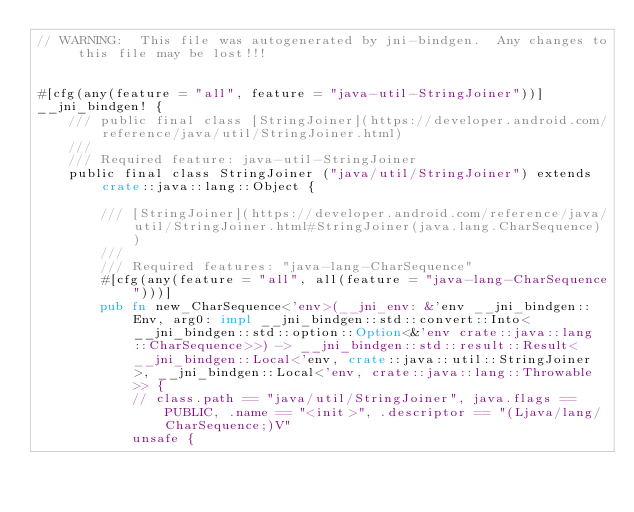Convert code to text. <code><loc_0><loc_0><loc_500><loc_500><_Rust_>// WARNING:  This file was autogenerated by jni-bindgen.  Any changes to this file may be lost!!!


#[cfg(any(feature = "all", feature = "java-util-StringJoiner"))]
__jni_bindgen! {
    /// public final class [StringJoiner](https://developer.android.com/reference/java/util/StringJoiner.html)
    ///
    /// Required feature: java-util-StringJoiner
    public final class StringJoiner ("java/util/StringJoiner") extends crate::java::lang::Object {

        /// [StringJoiner](https://developer.android.com/reference/java/util/StringJoiner.html#StringJoiner(java.lang.CharSequence))
        ///
        /// Required features: "java-lang-CharSequence"
        #[cfg(any(feature = "all", all(feature = "java-lang-CharSequence")))]
        pub fn new_CharSequence<'env>(__jni_env: &'env __jni_bindgen::Env, arg0: impl __jni_bindgen::std::convert::Into<__jni_bindgen::std::option::Option<&'env crate::java::lang::CharSequence>>) -> __jni_bindgen::std::result::Result<__jni_bindgen::Local<'env, crate::java::util::StringJoiner>, __jni_bindgen::Local<'env, crate::java::lang::Throwable>> {
            // class.path == "java/util/StringJoiner", java.flags == PUBLIC, .name == "<init>", .descriptor == "(Ljava/lang/CharSequence;)V"
            unsafe {</code> 